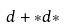Convert formula to latex. <formula><loc_0><loc_0><loc_500><loc_500>d + * d *</formula> 